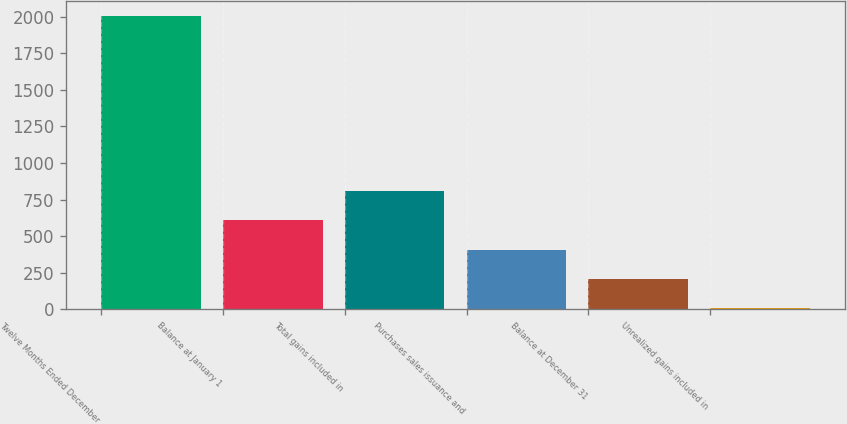Convert chart to OTSL. <chart><loc_0><loc_0><loc_500><loc_500><bar_chart><fcel>Twelve Months Ended December<fcel>Balance at January 1<fcel>Total gains included in<fcel>Purchases sales issuance and<fcel>Balance at December 31<fcel>Unrealized gains included in<nl><fcel>2009<fcel>606.9<fcel>807.2<fcel>406.6<fcel>206.3<fcel>6<nl></chart> 